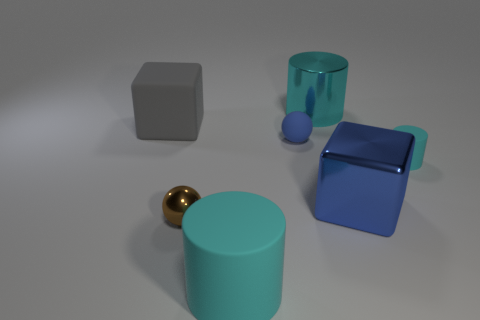How many things are either metal objects or rubber things behind the small cyan matte cylinder?
Offer a very short reply. 5. Do the block on the left side of the cyan shiny thing and the tiny blue rubber ball have the same size?
Your answer should be very brief. No. How many other objects are there of the same size as the shiny cylinder?
Your answer should be compact. 3. The small cylinder is what color?
Provide a succinct answer. Cyan. There is a big cyan object that is behind the brown shiny sphere; what is it made of?
Your response must be concise. Metal. Are there an equal number of big things to the right of the big shiny block and small purple rubber cubes?
Your answer should be very brief. Yes. Do the big blue metal object and the tiny brown metallic object have the same shape?
Provide a short and direct response. No. Are there any other things that are the same color as the large rubber cube?
Your answer should be very brief. No. There is a large thing that is in front of the small rubber cylinder and left of the large blue metallic object; what shape is it?
Make the answer very short. Cylinder. Are there an equal number of big cyan cylinders that are behind the small blue matte thing and big blocks to the right of the big rubber cylinder?
Your answer should be compact. Yes. 